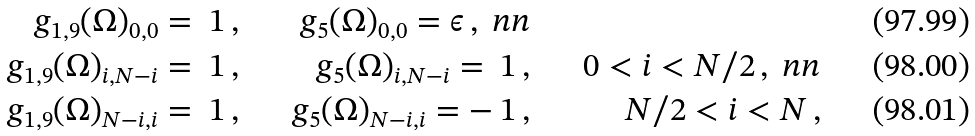Convert formula to latex. <formula><loc_0><loc_0><loc_500><loc_500>g _ { 1 , 9 } ( \Omega ) _ { 0 , 0 } = \ 1 \, , & & g _ { 5 } ( \Omega ) _ { 0 , 0 } = \epsilon \, , \ n n \\ g _ { 1 , 9 } ( \Omega ) _ { i , N - i } = \ 1 \, , & & g _ { 5 } ( \Omega ) _ { i , N - i } = \ 1 \, , & & 0 < i < N / 2 \, , \ n n \\ g _ { 1 , 9 } ( \Omega ) _ { N - i , i } = \ 1 \, , & & g _ { 5 } ( \Omega ) _ { N - i , i } = - \ 1 \, , & & N / 2 < i < N \, ,</formula> 